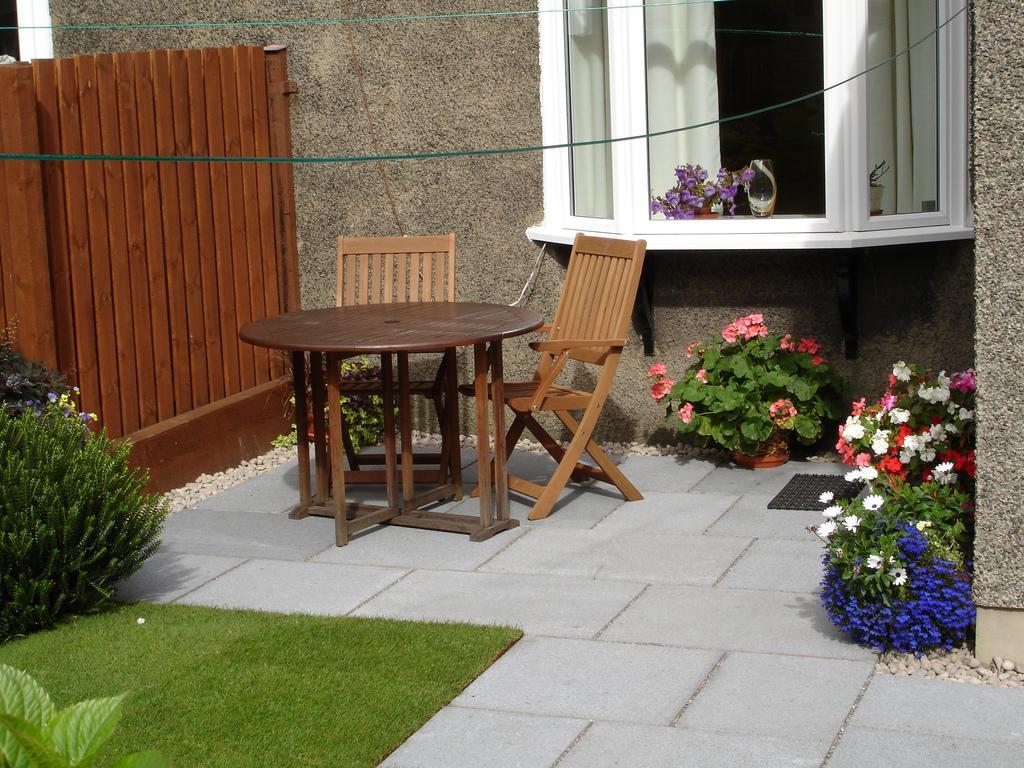How would you summarize this image in a sentence or two? We can see chair, table, plants and flowers. We can see wall,window and curtains. 